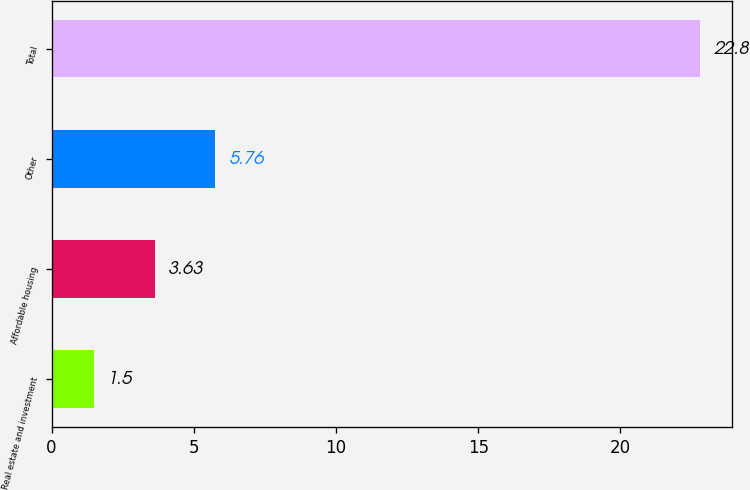Convert chart to OTSL. <chart><loc_0><loc_0><loc_500><loc_500><bar_chart><fcel>Real estate and investment<fcel>Affordable housing<fcel>Other<fcel>Total<nl><fcel>1.5<fcel>3.63<fcel>5.76<fcel>22.8<nl></chart> 